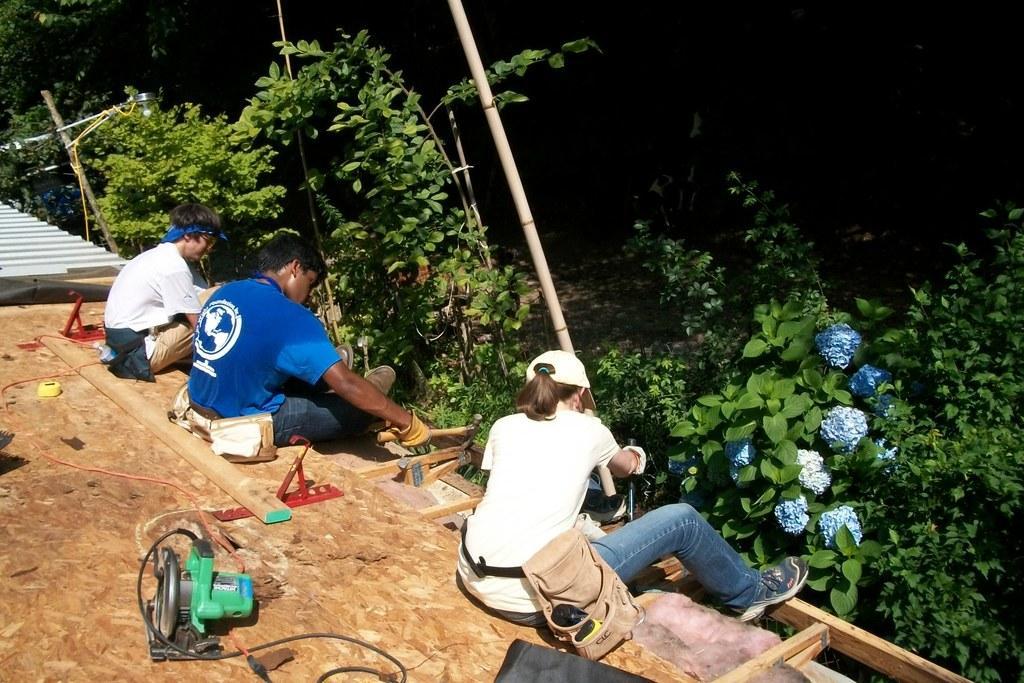Please provide a concise description of this image. In the center of the pictures there are plants, flowers, people, bamboo sticks, axe and other objects. In the foreground there is a wooden object on the wooden object there are machinery, tape, wooden log and other objects. On the right there are plants. On the left there are plants and a roof like object. 